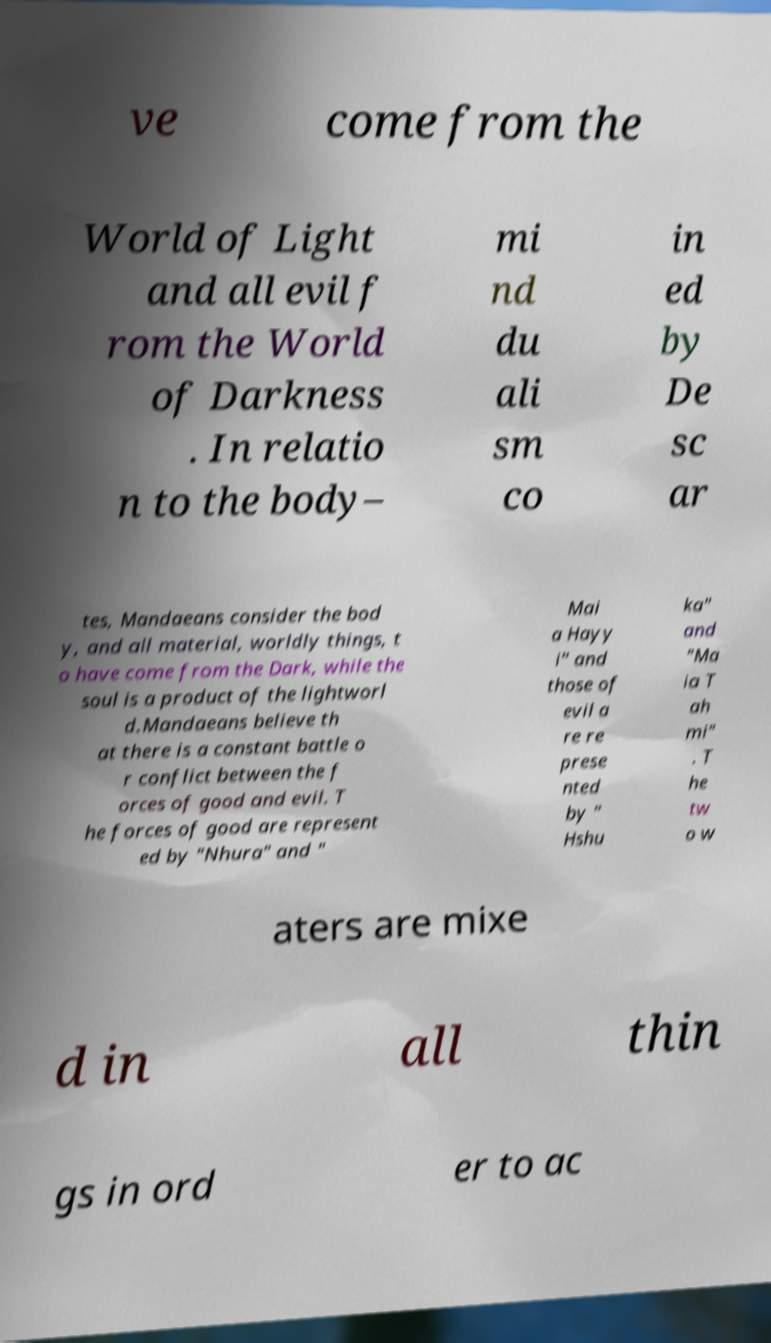There's text embedded in this image that I need extracted. Can you transcribe it verbatim? ve come from the World of Light and all evil f rom the World of Darkness . In relatio n to the body– mi nd du ali sm co in ed by De sc ar tes, Mandaeans consider the bod y, and all material, worldly things, t o have come from the Dark, while the soul is a product of the lightworl d.Mandaeans believe th at there is a constant battle o r conflict between the f orces of good and evil. T he forces of good are represent ed by "Nhura" and " Mai a Hayy i" and those of evil a re re prese nted by " Hshu ka" and "Ma ia T ah mi" . T he tw o w aters are mixe d in all thin gs in ord er to ac 